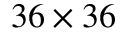Convert formula to latex. <formula><loc_0><loc_0><loc_500><loc_500>3 6 \times 3 6</formula> 